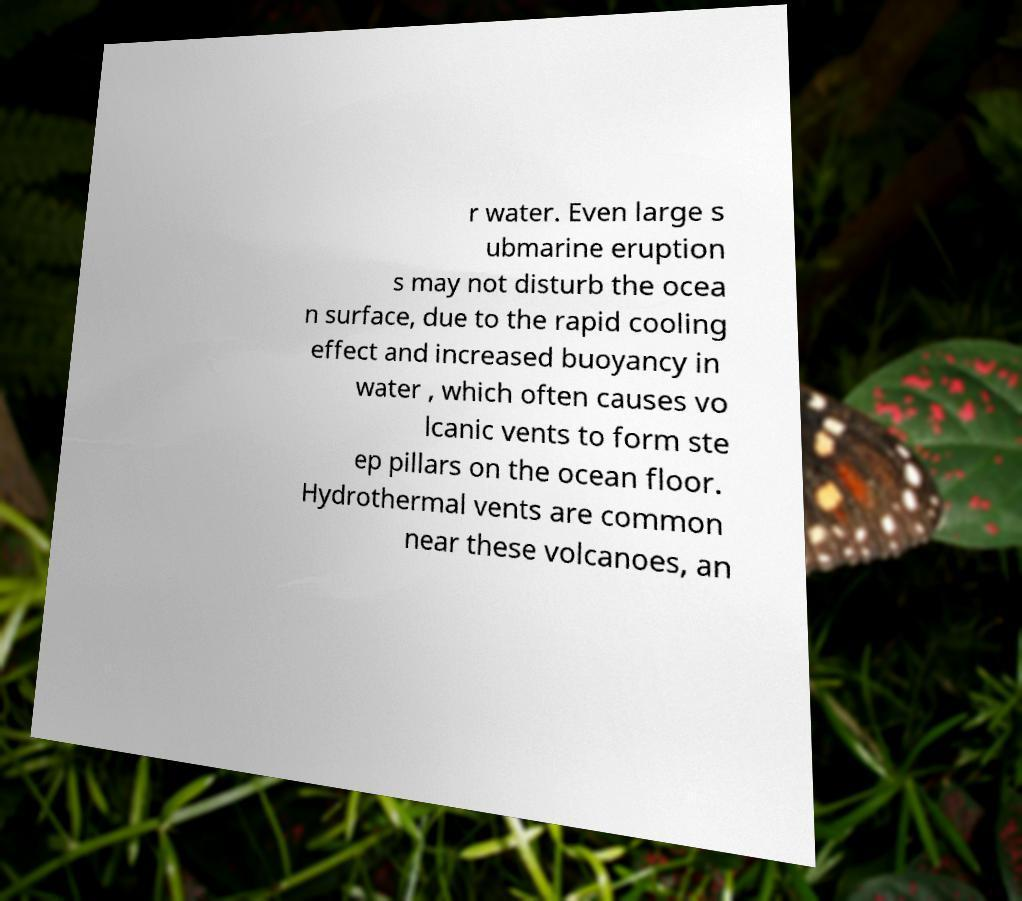Please read and relay the text visible in this image. What does it say? r water. Even large s ubmarine eruption s may not disturb the ocea n surface, due to the rapid cooling effect and increased buoyancy in water , which often causes vo lcanic vents to form ste ep pillars on the ocean floor. Hydrothermal vents are common near these volcanoes, an 